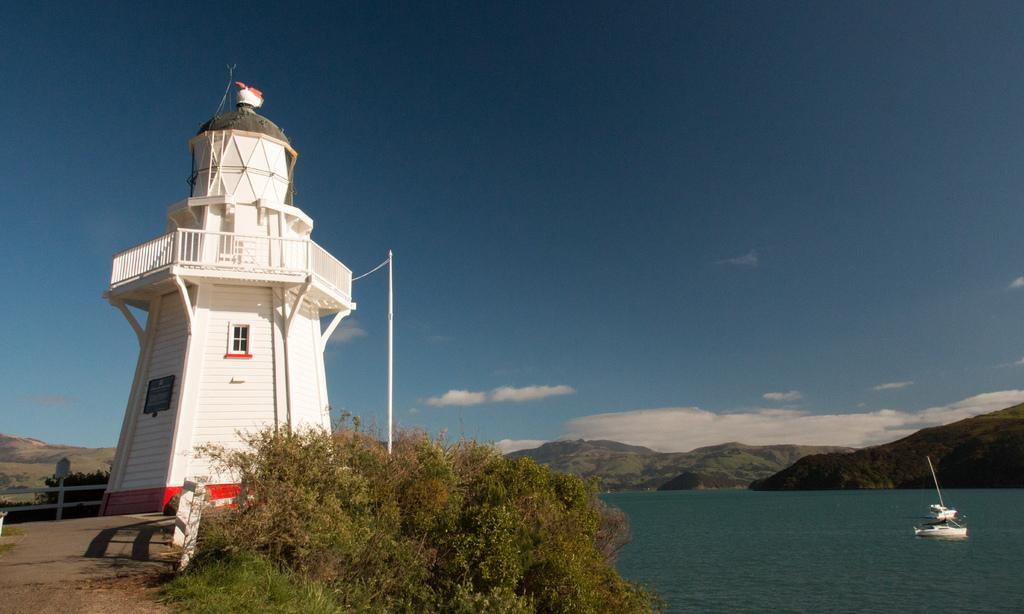What is the main structure in the image? There is a lighthouse in the image. What type of natural vegetation can be seen in the image? There are trees in the image. What is the object that is being rammed in the image? There is a ramming in the image, but it is not specified what is being rammed. What is floating on the water in the image? There is a boat on the water in the image. What type of landscape can be seen in the background of the image? There are mountains in the background of the image. What is visible in the sky in the image? The sky is visible in the background of the image, and clouds are present. What type of attraction is present in the image? There is no specific attraction mentioned in the image; it features a lighthouse, trees, a ramming, a boat, mountains, and a sky with clouds. 